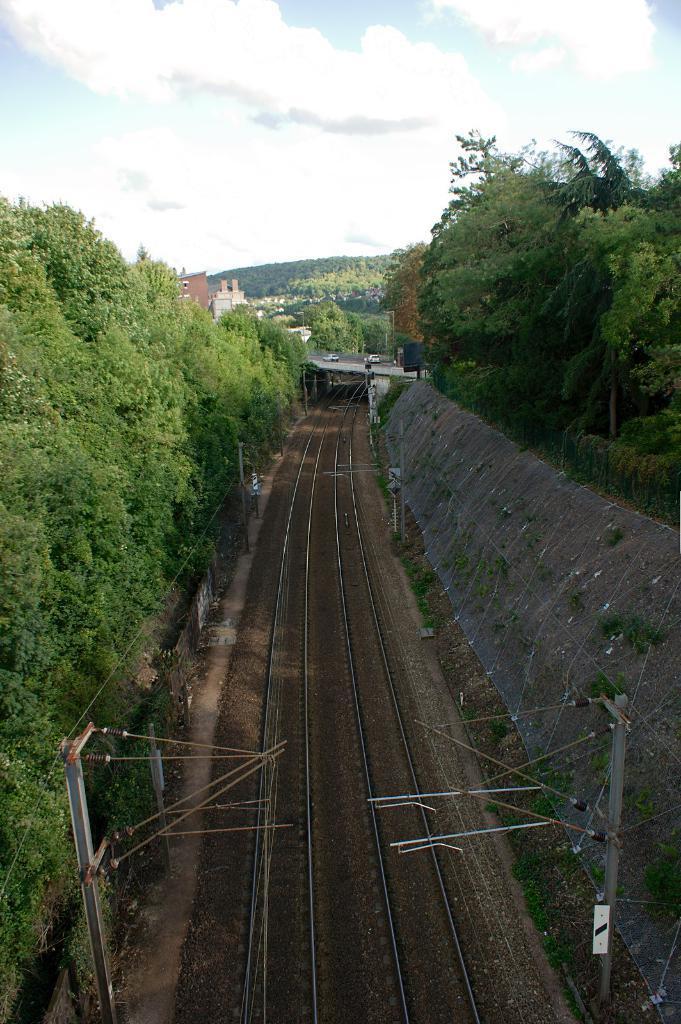How would you summarize this image in a sentence or two? In the center of the image, we can see a track and there are some poles. In the background, there are trees, buildings and some vehicles on the bridge. At the top, there are clouds in the sky. 